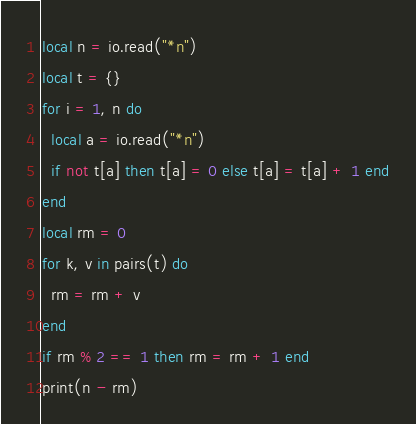Convert code to text. <code><loc_0><loc_0><loc_500><loc_500><_Lua_>local n = io.read("*n")
local t = {}
for i = 1, n do
  local a = io.read("*n")
  if not t[a] then t[a] = 0 else t[a] = t[a] + 1 end
end
local rm = 0
for k, v in pairs(t) do
  rm = rm + v
end
if rm % 2 == 1 then rm = rm + 1 end
print(n - rm)
</code> 